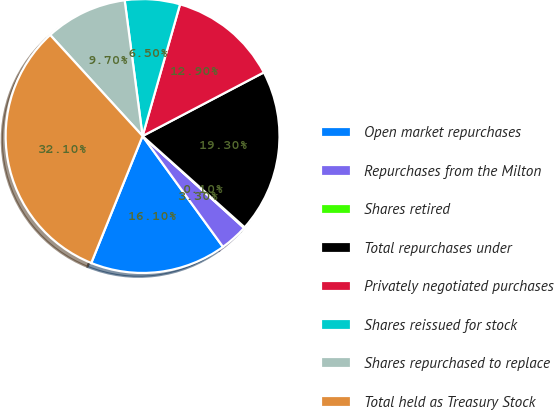Convert chart. <chart><loc_0><loc_0><loc_500><loc_500><pie_chart><fcel>Open market repurchases<fcel>Repurchases from the Milton<fcel>Shares retired<fcel>Total repurchases under<fcel>Privately negotiated purchases<fcel>Shares reissued for stock<fcel>Shares repurchased to replace<fcel>Total held as Treasury Stock<nl><fcel>16.1%<fcel>3.3%<fcel>0.1%<fcel>19.3%<fcel>12.9%<fcel>6.5%<fcel>9.7%<fcel>32.1%<nl></chart> 